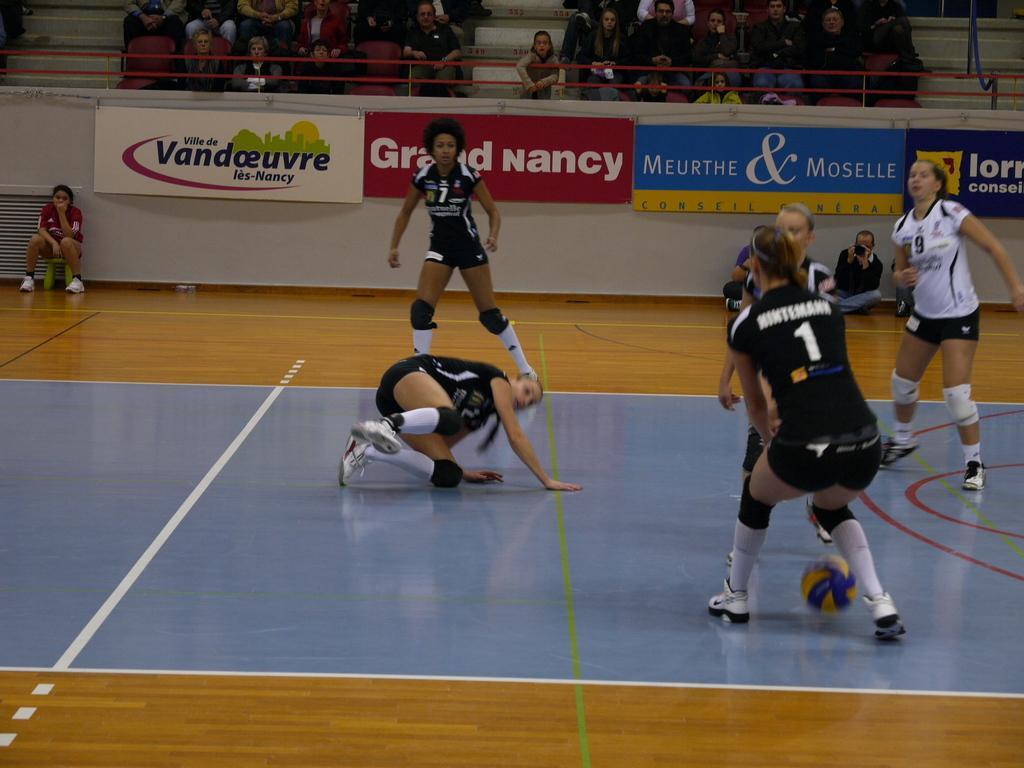In one or two sentences, can you explain what this image depicts? In this image I can see crowd visible at back side of fence at the top , in front of fence I can see a woman sitting on table on the left side and there are few persons playing a game on the floor and a ball visible on the floor and a person holding a mobile sitting on floor in front of fence. 